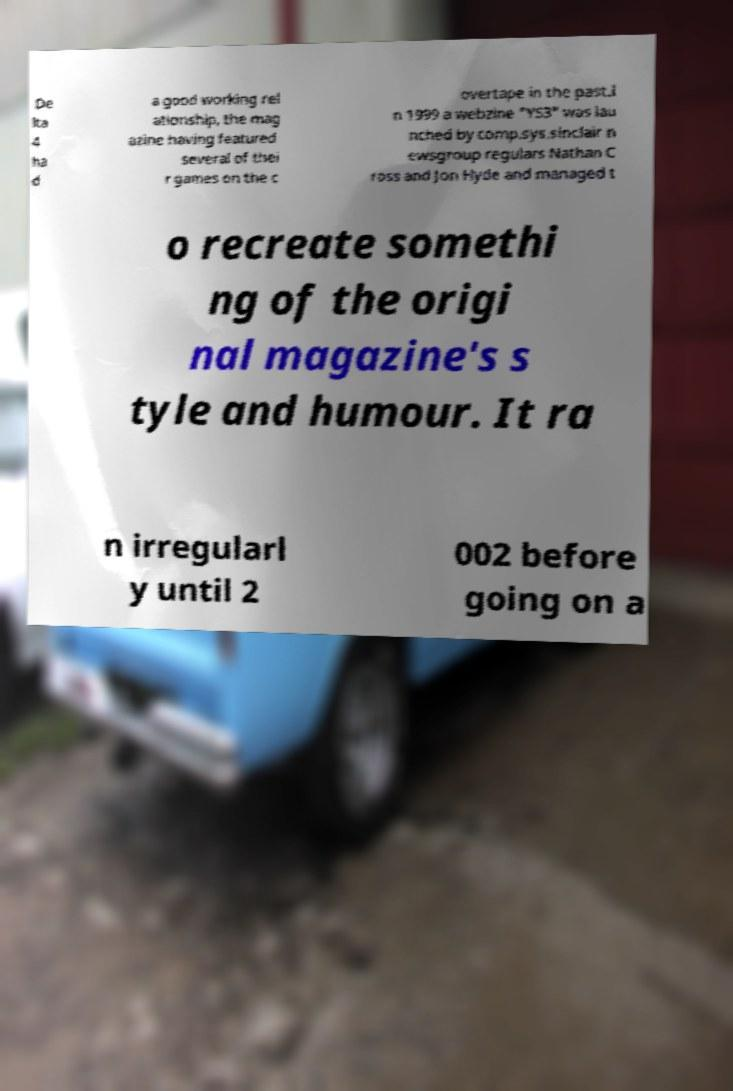Can you read and provide the text displayed in the image?This photo seems to have some interesting text. Can you extract and type it out for me? De lta 4 ha d a good working rel ationship, the mag azine having featured several of thei r games on the c overtape in the past.I n 1999 a webzine "YS3" was lau nched by comp.sys.sinclair n ewsgroup regulars Nathan C ross and Jon Hyde and managed t o recreate somethi ng of the origi nal magazine's s tyle and humour. It ra n irregularl y until 2 002 before going on a 